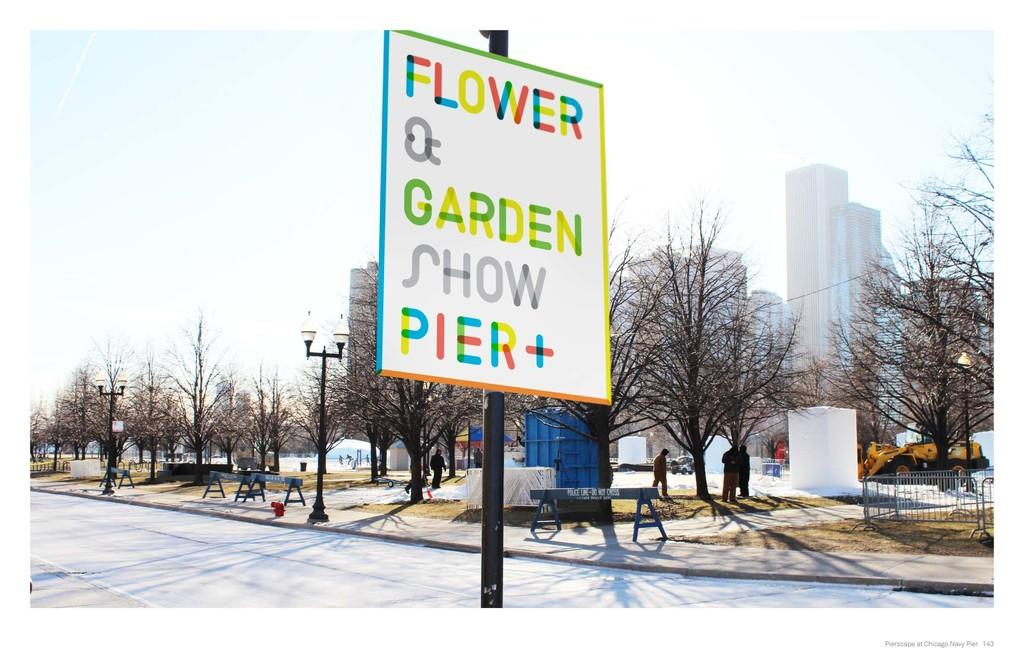<image>
Offer a succinct explanation of the picture presented. A street sign indicates the location of a flower and gardens show. 